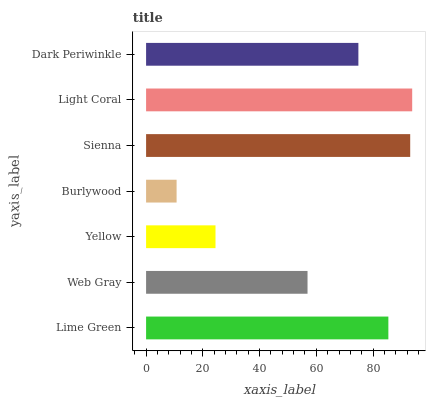Is Burlywood the minimum?
Answer yes or no. Yes. Is Light Coral the maximum?
Answer yes or no. Yes. Is Web Gray the minimum?
Answer yes or no. No. Is Web Gray the maximum?
Answer yes or no. No. Is Lime Green greater than Web Gray?
Answer yes or no. Yes. Is Web Gray less than Lime Green?
Answer yes or no. Yes. Is Web Gray greater than Lime Green?
Answer yes or no. No. Is Lime Green less than Web Gray?
Answer yes or no. No. Is Dark Periwinkle the high median?
Answer yes or no. Yes. Is Dark Periwinkle the low median?
Answer yes or no. Yes. Is Yellow the high median?
Answer yes or no. No. Is Light Coral the low median?
Answer yes or no. No. 